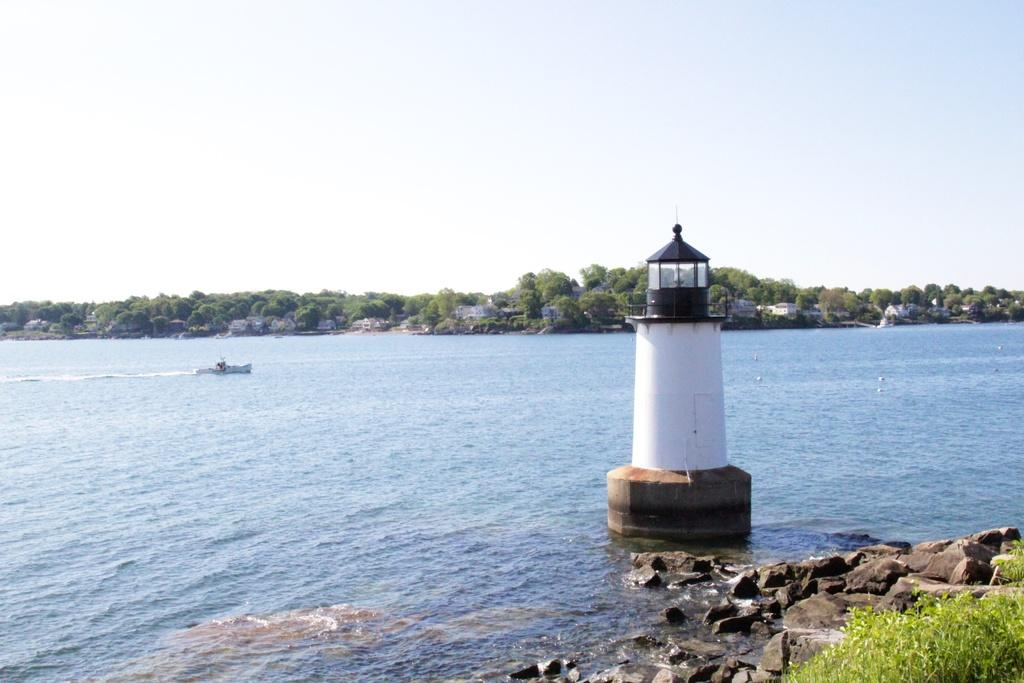What structure is located on the right side of the image? There is a lighthouse on the right side of the image. What is in the water on the left side of the image? There is a boat in the ocean on the left side of the image. What type of vegetation is in the background of the image? There are trees in the background of the image. What is visible in the background of the image besides the trees? The sky is visible in the background of the image. What country is the lighthouse located in, according to the image? The image does not provide information about the country where the lighthouse is located. What is the name of the downtown area near the boat in the image? The image does not provide information about any downtown area near the boat. 